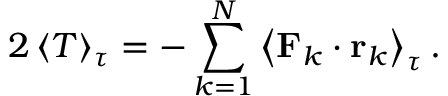<formula> <loc_0><loc_0><loc_500><loc_500>2 \left \langle T \right \rangle _ { \tau } = - \sum _ { k = 1 } ^ { N } \left \langle F _ { k } \cdot r _ { k } \right \rangle _ { \tau } .</formula> 